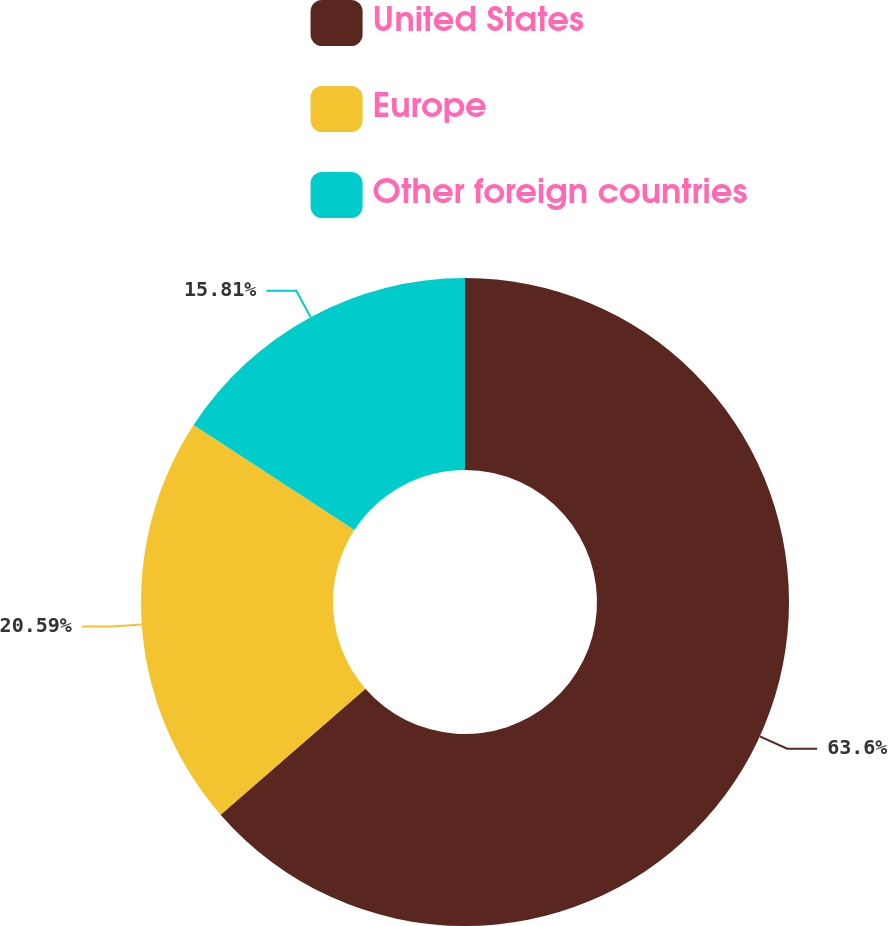Convert chart to OTSL. <chart><loc_0><loc_0><loc_500><loc_500><pie_chart><fcel>United States<fcel>Europe<fcel>Other foreign countries<nl><fcel>63.61%<fcel>20.59%<fcel>15.81%<nl></chart> 